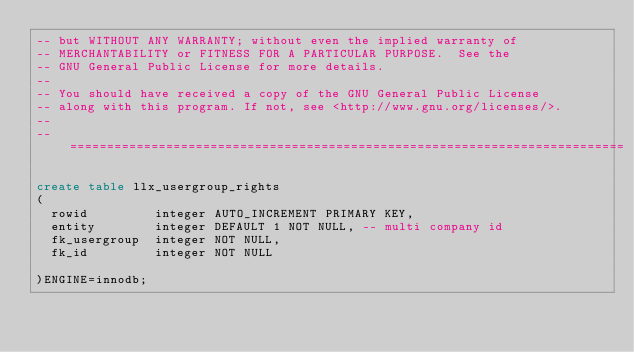Convert code to text. <code><loc_0><loc_0><loc_500><loc_500><_SQL_>-- but WITHOUT ANY WARRANTY; without even the implied warranty of
-- MERCHANTABILITY or FITNESS FOR A PARTICULAR PURPOSE.  See the
-- GNU General Public License for more details.
--
-- You should have received a copy of the GNU General Public License
-- along with this program. If not, see <http://www.gnu.org/licenses/>.
--
-- ===========================================================================

create table llx_usergroup_rights
(
  rowid			integer AUTO_INCREMENT PRIMARY KEY,
  entity		integer DEFAULT 1 NOT NULL, -- multi company id
  fk_usergroup	integer NOT NULL,
  fk_id			integer NOT NULL

)ENGINE=innodb;

</code> 